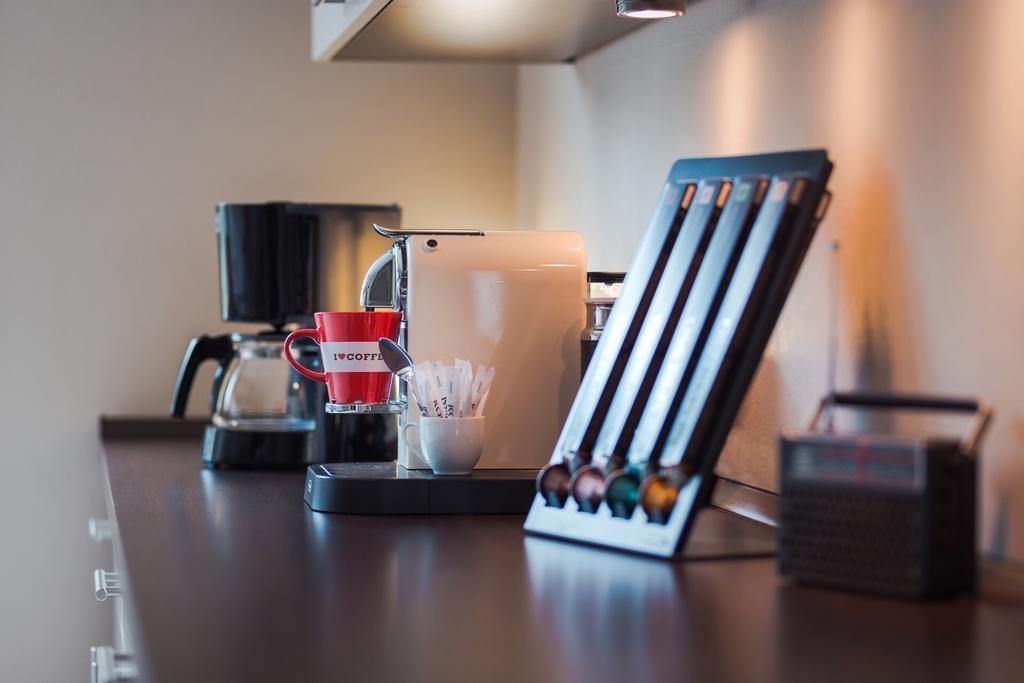Could you give a brief overview of what you see in this image? In this image, we can see some objects like cups and on the table. Among them, we can see a cup with some objects and a spoon. 